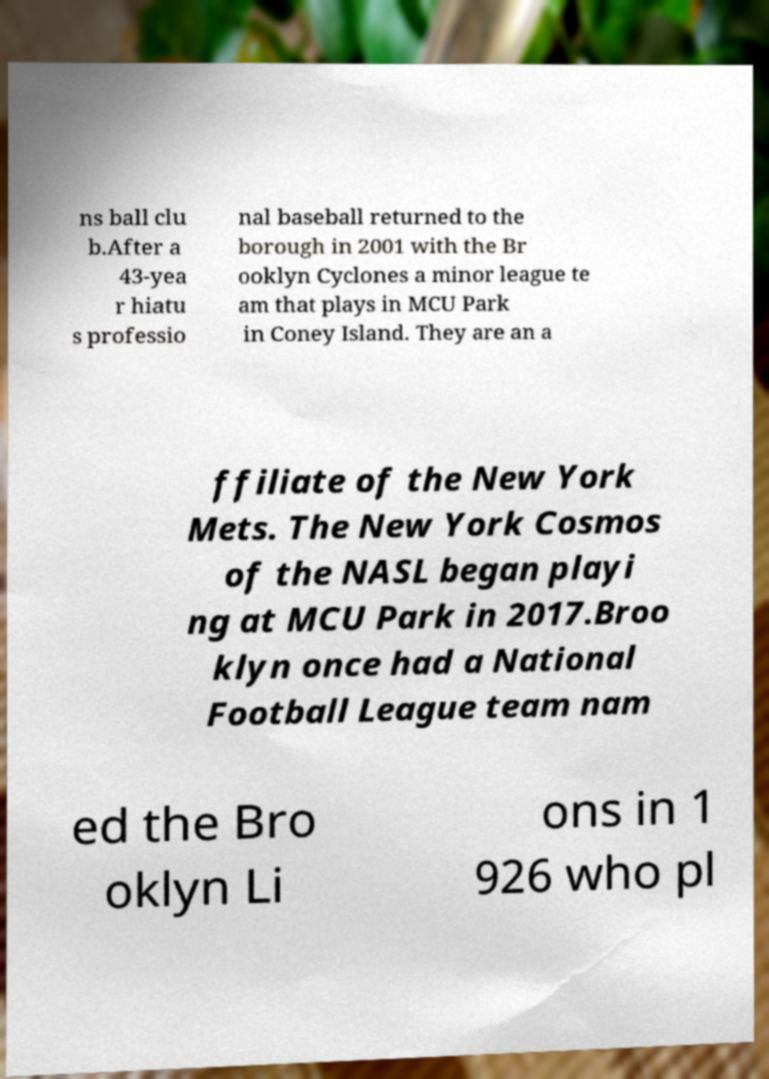What messages or text are displayed in this image? I need them in a readable, typed format. ns ball clu b.After a 43-yea r hiatu s professio nal baseball returned to the borough in 2001 with the Br ooklyn Cyclones a minor league te am that plays in MCU Park in Coney Island. They are an a ffiliate of the New York Mets. The New York Cosmos of the NASL began playi ng at MCU Park in 2017.Broo klyn once had a National Football League team nam ed the Bro oklyn Li ons in 1 926 who pl 